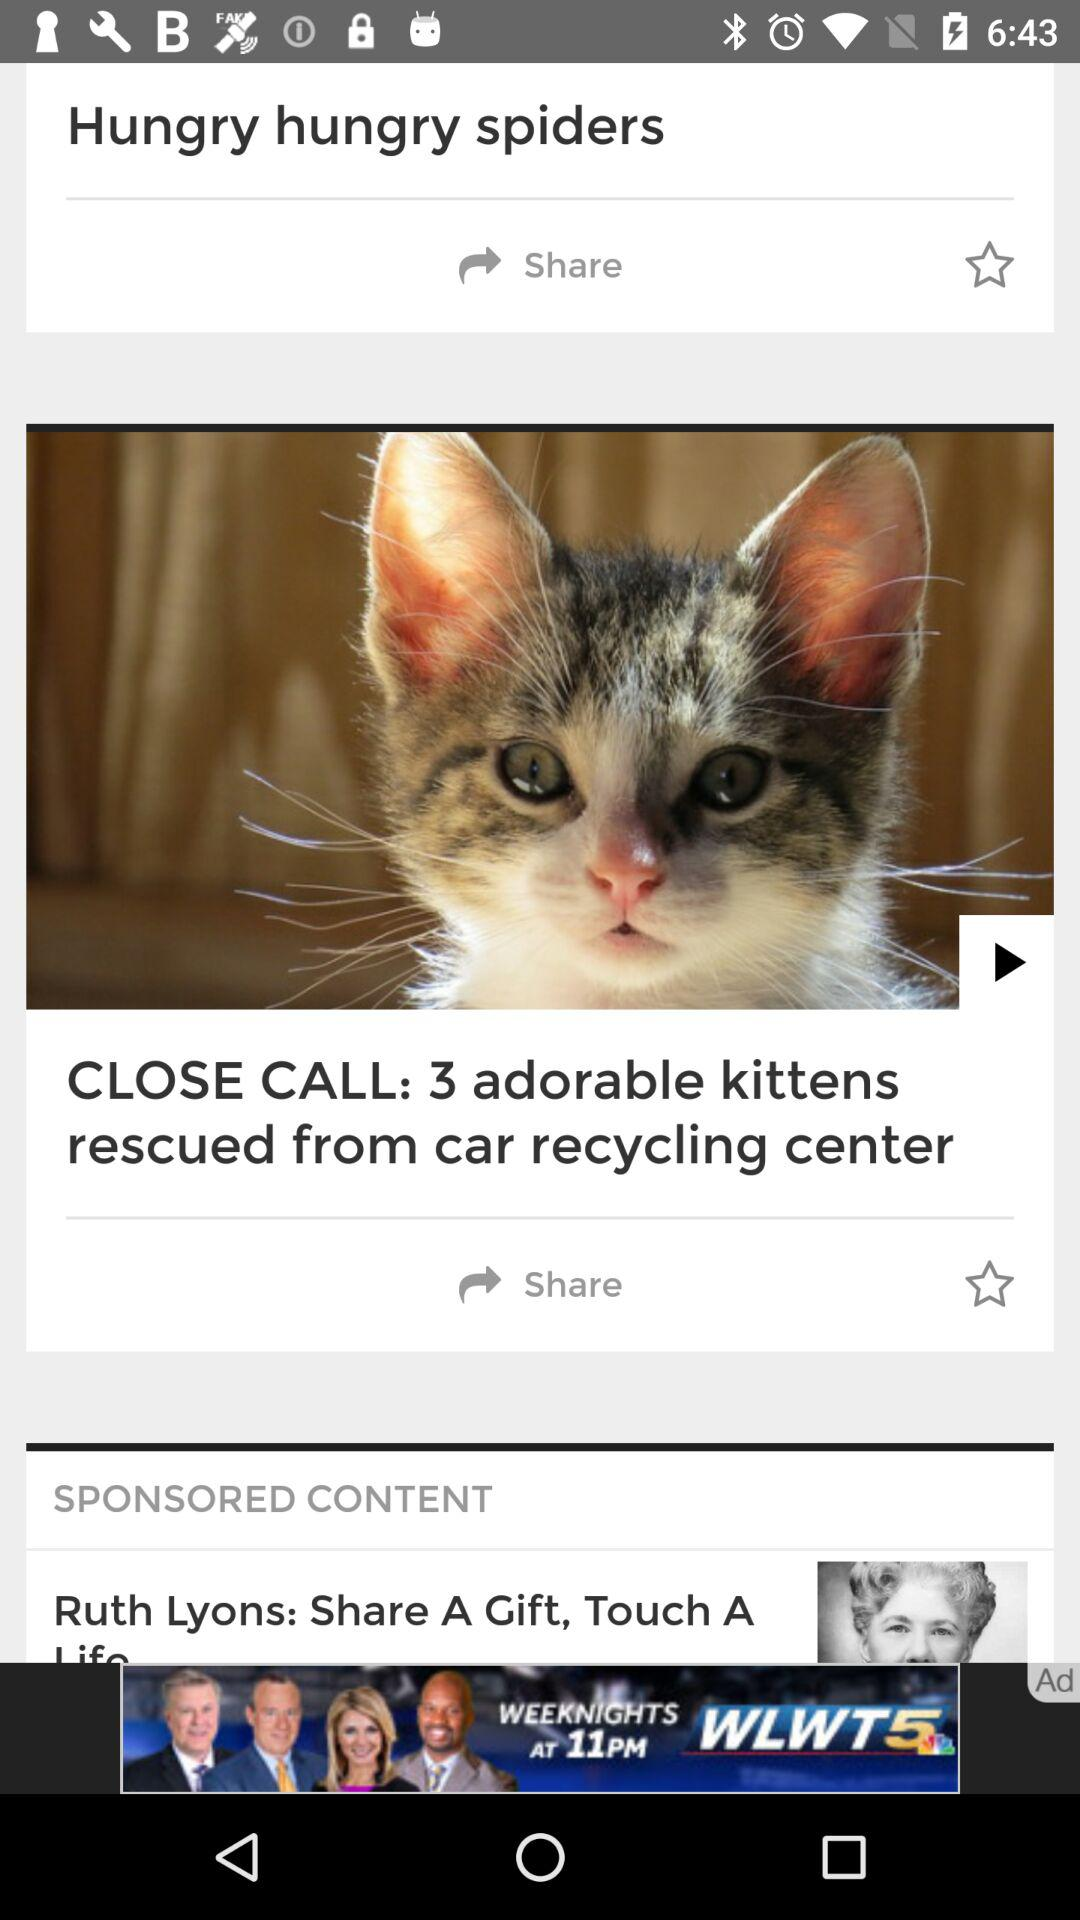How many kittens are rescued from the car recycling center? There are 3 kittens rescued from the car recycling center. 